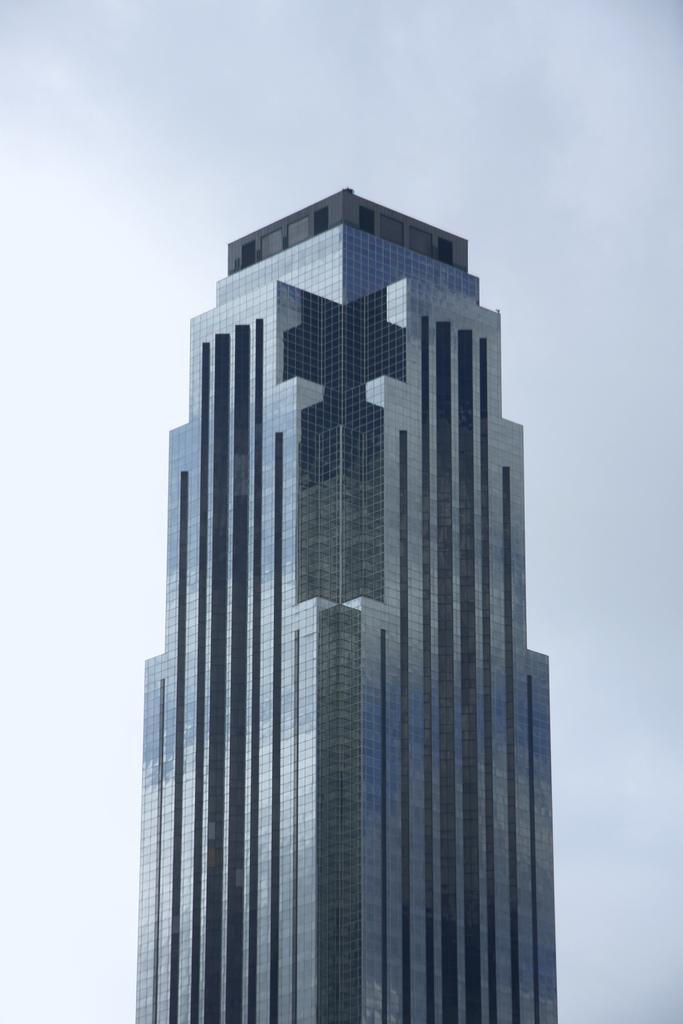What type of building is in the image? There is a skyscraper in the image. What is visible at the top of the image? The sky is visible at the top of the image. What can be seen in the sky? Clouds are present in the sky. What type of knot is being tied by the clouds in the image? There is no knot being tied by the clouds in the image; clouds are a natural atmospheric phenomenon and do not form knots. 